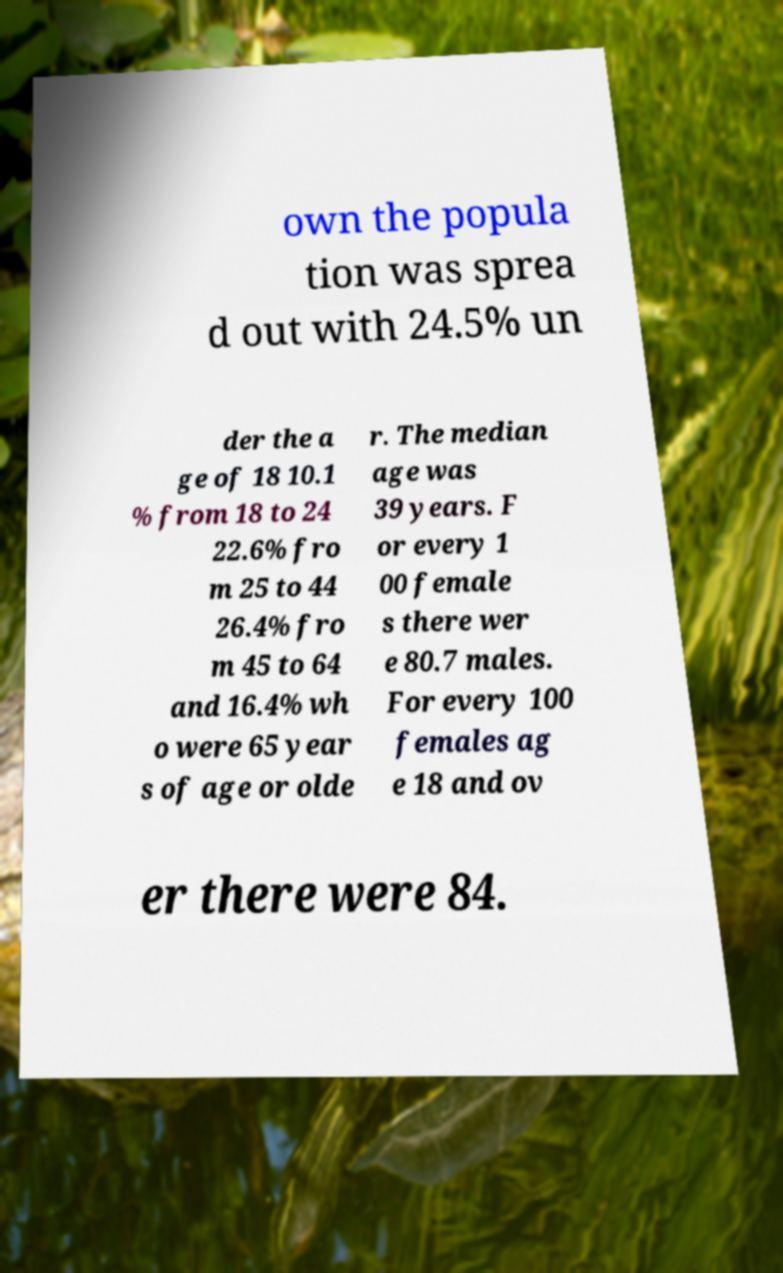There's text embedded in this image that I need extracted. Can you transcribe it verbatim? own the popula tion was sprea d out with 24.5% un der the a ge of 18 10.1 % from 18 to 24 22.6% fro m 25 to 44 26.4% fro m 45 to 64 and 16.4% wh o were 65 year s of age or olde r. The median age was 39 years. F or every 1 00 female s there wer e 80.7 males. For every 100 females ag e 18 and ov er there were 84. 